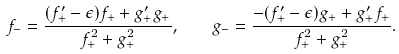Convert formula to latex. <formula><loc_0><loc_0><loc_500><loc_500>f _ { - } = \frac { ( f ^ { \prime } _ { + } - \epsilon ) f _ { + } + g ^ { \prime } _ { + } g _ { + } } { f _ { + } ^ { 2 } + g _ { + } ^ { 2 } } , \quad g _ { - } = \frac { - ( f ^ { \prime } _ { + } - \epsilon ) g _ { + } + g ^ { \prime } _ { + } f _ { + } } { f _ { + } ^ { 2 } + g _ { + } ^ { 2 } } .</formula> 